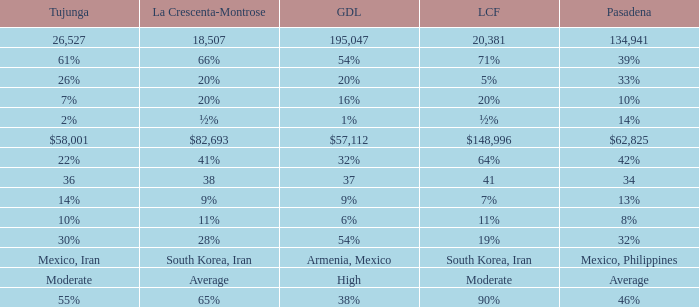When La Crescenta-Montrose has 66%, what is Tujunga? 61%. 